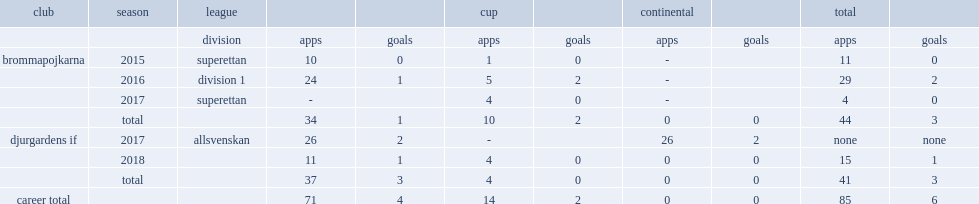In 2017, which league did beijmo appear for side djurgardens if? Allsvenskan. 